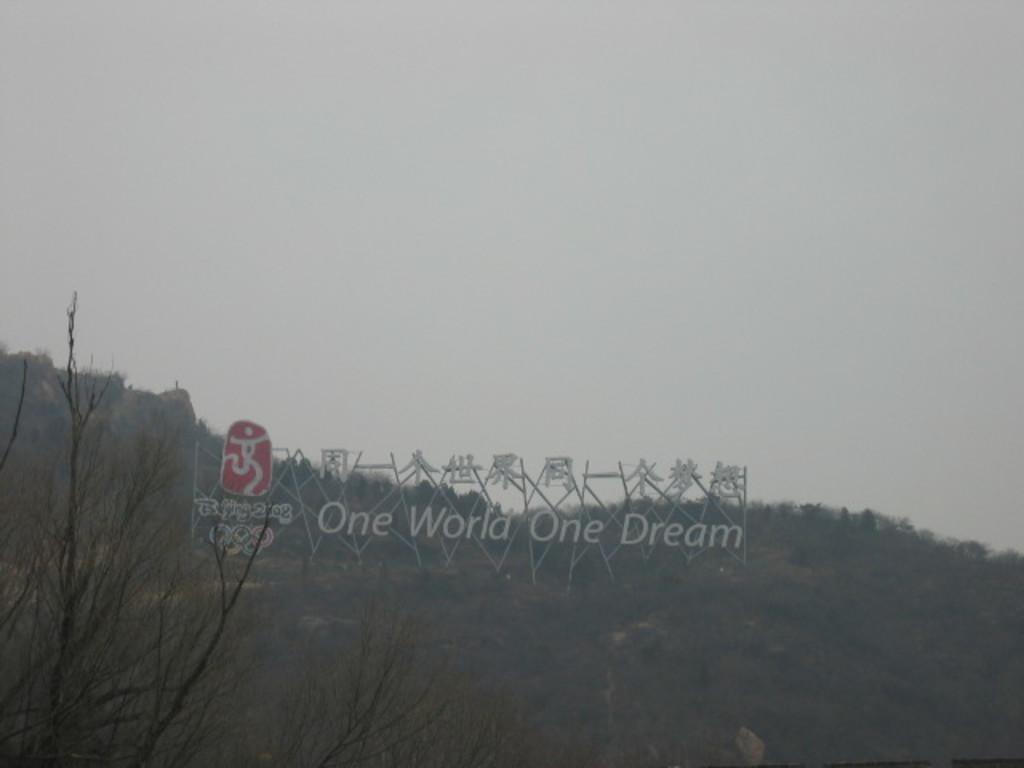How would you summarize this image in a sentence or two? On the left side, there is a tree. At the bottom of this image, there is a hoarding arranged on a hill, on which there are trees and grass. In the background, there are clouds in the sky. 